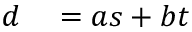<formula> <loc_0><loc_0><loc_500><loc_500>\begin{array} { r l } { d } & = a s + b t } \end{array}</formula> 